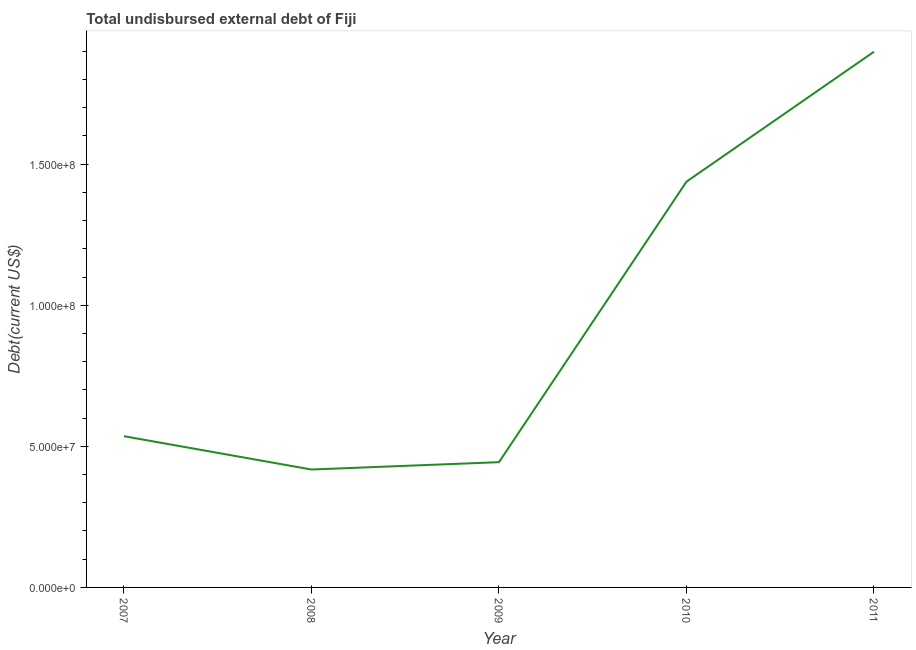What is the total debt in 2008?
Offer a very short reply. 4.18e+07. Across all years, what is the maximum total debt?
Offer a terse response. 1.90e+08. Across all years, what is the minimum total debt?
Your answer should be compact. 4.18e+07. In which year was the total debt maximum?
Ensure brevity in your answer.  2011. What is the sum of the total debt?
Your answer should be very brief. 4.73e+08. What is the difference between the total debt in 2007 and 2009?
Keep it short and to the point. 9.20e+06. What is the average total debt per year?
Your answer should be compact. 9.47e+07. What is the median total debt?
Make the answer very short. 5.36e+07. In how many years, is the total debt greater than 160000000 US$?
Your answer should be very brief. 1. What is the ratio of the total debt in 2008 to that in 2009?
Make the answer very short. 0.94. Is the total debt in 2008 less than that in 2009?
Your response must be concise. Yes. What is the difference between the highest and the second highest total debt?
Offer a very short reply. 4.60e+07. Is the sum of the total debt in 2008 and 2011 greater than the maximum total debt across all years?
Your answer should be compact. Yes. What is the difference between the highest and the lowest total debt?
Keep it short and to the point. 1.48e+08. How many lines are there?
Provide a succinct answer. 1. How many years are there in the graph?
Give a very brief answer. 5. Does the graph contain grids?
Give a very brief answer. No. What is the title of the graph?
Give a very brief answer. Total undisbursed external debt of Fiji. What is the label or title of the Y-axis?
Ensure brevity in your answer.  Debt(current US$). What is the Debt(current US$) in 2007?
Give a very brief answer. 5.36e+07. What is the Debt(current US$) in 2008?
Keep it short and to the point. 4.18e+07. What is the Debt(current US$) in 2009?
Offer a very short reply. 4.44e+07. What is the Debt(current US$) in 2010?
Offer a terse response. 1.44e+08. What is the Debt(current US$) of 2011?
Offer a terse response. 1.90e+08. What is the difference between the Debt(current US$) in 2007 and 2008?
Provide a succinct answer. 1.18e+07. What is the difference between the Debt(current US$) in 2007 and 2009?
Keep it short and to the point. 9.20e+06. What is the difference between the Debt(current US$) in 2007 and 2010?
Provide a succinct answer. -9.02e+07. What is the difference between the Debt(current US$) in 2007 and 2011?
Your answer should be compact. -1.36e+08. What is the difference between the Debt(current US$) in 2008 and 2009?
Your answer should be compact. -2.61e+06. What is the difference between the Debt(current US$) in 2008 and 2010?
Your response must be concise. -1.02e+08. What is the difference between the Debt(current US$) in 2008 and 2011?
Give a very brief answer. -1.48e+08. What is the difference between the Debt(current US$) in 2009 and 2010?
Ensure brevity in your answer.  -9.94e+07. What is the difference between the Debt(current US$) in 2009 and 2011?
Offer a very short reply. -1.45e+08. What is the difference between the Debt(current US$) in 2010 and 2011?
Keep it short and to the point. -4.60e+07. What is the ratio of the Debt(current US$) in 2007 to that in 2008?
Offer a very short reply. 1.28. What is the ratio of the Debt(current US$) in 2007 to that in 2009?
Keep it short and to the point. 1.21. What is the ratio of the Debt(current US$) in 2007 to that in 2010?
Your answer should be compact. 0.37. What is the ratio of the Debt(current US$) in 2007 to that in 2011?
Provide a short and direct response. 0.28. What is the ratio of the Debt(current US$) in 2008 to that in 2009?
Your answer should be compact. 0.94. What is the ratio of the Debt(current US$) in 2008 to that in 2010?
Your answer should be very brief. 0.29. What is the ratio of the Debt(current US$) in 2008 to that in 2011?
Offer a terse response. 0.22. What is the ratio of the Debt(current US$) in 2009 to that in 2010?
Your answer should be very brief. 0.31. What is the ratio of the Debt(current US$) in 2009 to that in 2011?
Ensure brevity in your answer.  0.23. What is the ratio of the Debt(current US$) in 2010 to that in 2011?
Offer a very short reply. 0.76. 